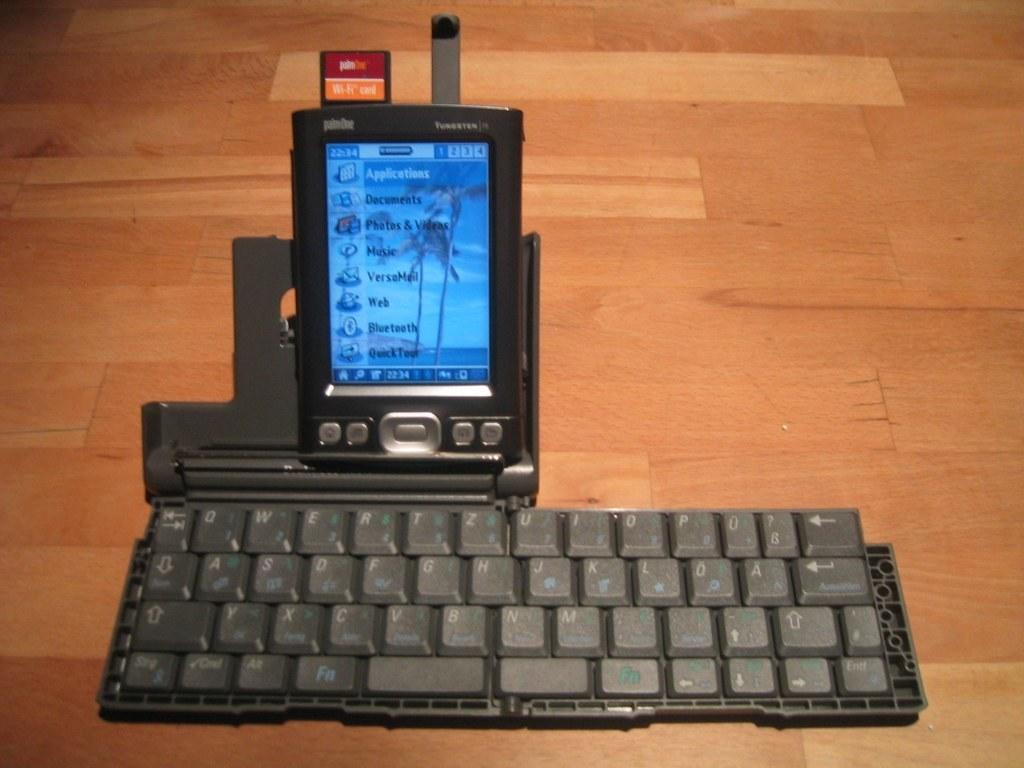Provide a one-sentence caption for the provided image. a palmOne phone hooked up to a keyboard on a wooden table. 